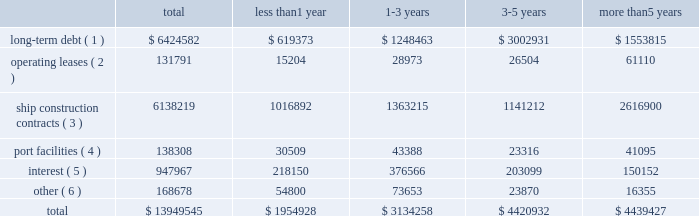Off-balance sheet transactions contractual obligations as of december 31 , 2017 , our contractual obligations with initial or remaining terms in excess of one year , including interest payments on long-term debt obligations , were as follows ( in thousands ) : the table above does not include $ 0.5 million of unrecognized tax benefits ( we refer you to the notes to the consolidated financial statements note 201410 201cincome tax 201d ) .
Certain service providers may require collateral in the normal course of our business .
The amount of collateral may change based on certain terms and conditions .
As a routine part of our business , depending on market conditions , exchange rates , pricing and our strategy for growth , we regularly consider opportunities to enter into contracts for the building of additional ships .
We may also consider the sale of ships , potential acquisitions and strategic alliances .
If any of these transactions were to occur , they may be financed through the incurrence of additional permitted indebtedness , through cash flows from operations , or through the issuance of debt , equity or equity-related securities .
Funding sources certain of our debt agreements contain covenants that , among other things , require us to maintain a minimum level of liquidity , as well as limit our net funded debt-to-capital ratio , maintain certain other ratios and restrict our ability to pay dividends .
Substantially all of our ships and other property and equipment are pledged as collateral for certain of our debt .
We believe we were in compliance with these covenants as of december 31 , 2017 .
The impact of changes in world economies and especially the global credit markets can create a challenging environment and may reduce future consumer demand for cruises and adversely affect our counterparty credit risks .
In the event this environment deteriorates , our business , financial condition and results of operations could be adversely impacted .
We believe our cash on hand , expected future operating cash inflows , additional available borrowings under our new revolving loan facility and our ability to issue debt securities or additional equity securities , will be sufficient to fund operations , debt payment requirements , capital expenditures and maintain compliance with covenants under our debt agreements over the next twelve-month period .
There is no assurance that cash flows from operations and additional financings will be available in the future to fund our future obligations .
Less than 1 year 1-3 years 3-5 years more than 5 years long-term debt ( 1 ) $ 6424582 $ 619373 $ 1248463 $ 3002931 $ 1553815 operating leases ( 2 ) 131791 15204 28973 26504 61110 ship construction contracts ( 3 ) 6138219 1016892 1363215 1141212 2616900 port facilities ( 4 ) 138308 30509 43388 23316 41095 interest ( 5 ) 947967 218150 376566 203099 150152 other ( 6 ) 168678 54800 73653 23870 16355 .
( 1 ) includes discount and premiums aggregating $ 0.5 million .
Also includes capital leases .
The amount excludes deferred financing fees which are included in the consolidated balance sheets as an offset to long-term debt .
( 2 ) primarily for offices , motor vehicles and office equipment .
( 3 ) for our newbuild ships based on the euro/u.s .
Dollar exchange rate as of december 31 , 2017 .
Export credit financing is in place from syndicates of banks .
( 4 ) primarily for our usage of certain port facilities .
( 5 ) includes fixed and variable rates with libor held constant as of december 31 , 2017 .
( 6 ) future commitments for service , maintenance and other business enhancement capital expenditure contracts. .
What portion of the expected payments within the next 12 months is allocated to the repayment of long-term debt? 
Computations: (619373 / 1954928)
Answer: 0.31683. 